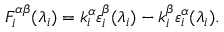Convert formula to latex. <formula><loc_0><loc_0><loc_500><loc_500>F _ { i } ^ { \alpha \beta } ( \lambda _ { i } ) = k _ { i } ^ { \alpha } \varepsilon _ { i } ^ { \beta } ( \lambda _ { i } ) - k _ { i } ^ { \beta } \varepsilon _ { i } ^ { \alpha } ( \lambda _ { i } ) .</formula> 